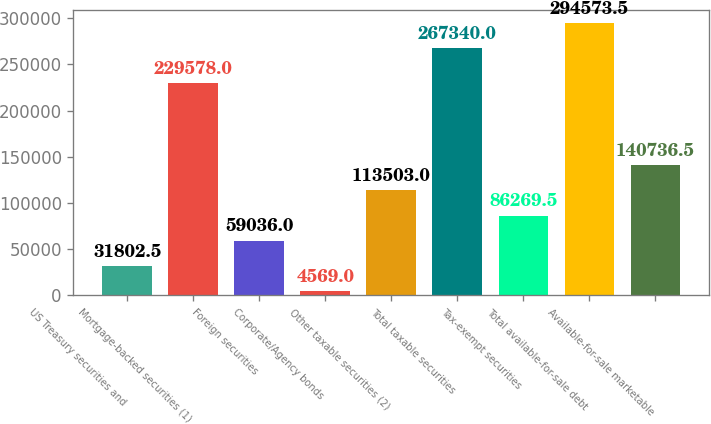<chart> <loc_0><loc_0><loc_500><loc_500><bar_chart><fcel>US Treasury securities and<fcel>Mortgage-backed securities (1)<fcel>Foreign securities<fcel>Corporate/Agency bonds<fcel>Other taxable securities (2)<fcel>Total taxable securities<fcel>Tax-exempt securities<fcel>Total available-for-sale debt<fcel>Available-for-sale marketable<nl><fcel>31802.5<fcel>229578<fcel>59036<fcel>4569<fcel>113503<fcel>267340<fcel>86269.5<fcel>294574<fcel>140736<nl></chart> 